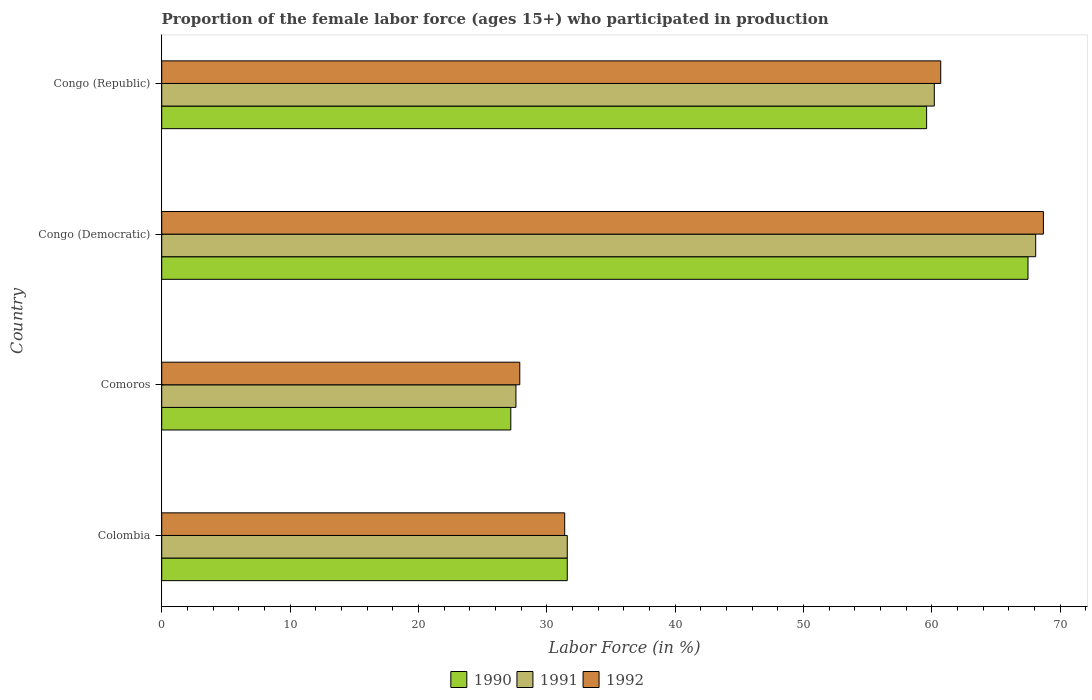How many groups of bars are there?
Provide a short and direct response. 4. Are the number of bars on each tick of the Y-axis equal?
Provide a succinct answer. Yes. What is the label of the 2nd group of bars from the top?
Offer a very short reply. Congo (Democratic). What is the proportion of the female labor force who participated in production in 1990 in Comoros?
Offer a terse response. 27.2. Across all countries, what is the maximum proportion of the female labor force who participated in production in 1992?
Provide a succinct answer. 68.7. Across all countries, what is the minimum proportion of the female labor force who participated in production in 1990?
Ensure brevity in your answer.  27.2. In which country was the proportion of the female labor force who participated in production in 1990 maximum?
Provide a succinct answer. Congo (Democratic). In which country was the proportion of the female labor force who participated in production in 1990 minimum?
Provide a short and direct response. Comoros. What is the total proportion of the female labor force who participated in production in 1991 in the graph?
Provide a short and direct response. 187.5. What is the difference between the proportion of the female labor force who participated in production in 1991 in Congo (Democratic) and that in Congo (Republic)?
Your answer should be compact. 7.9. What is the difference between the proportion of the female labor force who participated in production in 1991 in Comoros and the proportion of the female labor force who participated in production in 1990 in Colombia?
Your answer should be compact. -4. What is the average proportion of the female labor force who participated in production in 1992 per country?
Give a very brief answer. 47.17. What is the difference between the proportion of the female labor force who participated in production in 1992 and proportion of the female labor force who participated in production in 1990 in Colombia?
Your response must be concise. -0.2. What is the ratio of the proportion of the female labor force who participated in production in 1991 in Colombia to that in Comoros?
Ensure brevity in your answer.  1.14. What is the difference between the highest and the second highest proportion of the female labor force who participated in production in 1990?
Offer a very short reply. 7.9. What is the difference between the highest and the lowest proportion of the female labor force who participated in production in 1990?
Offer a very short reply. 40.3. Is the sum of the proportion of the female labor force who participated in production in 1990 in Congo (Democratic) and Congo (Republic) greater than the maximum proportion of the female labor force who participated in production in 1991 across all countries?
Offer a very short reply. Yes. How many bars are there?
Provide a succinct answer. 12. Are all the bars in the graph horizontal?
Give a very brief answer. Yes. Are the values on the major ticks of X-axis written in scientific E-notation?
Ensure brevity in your answer.  No. Does the graph contain any zero values?
Give a very brief answer. No. What is the title of the graph?
Provide a short and direct response. Proportion of the female labor force (ages 15+) who participated in production. Does "1984" appear as one of the legend labels in the graph?
Your response must be concise. No. What is the label or title of the X-axis?
Give a very brief answer. Labor Force (in %). What is the Labor Force (in %) in 1990 in Colombia?
Give a very brief answer. 31.6. What is the Labor Force (in %) in 1991 in Colombia?
Your response must be concise. 31.6. What is the Labor Force (in %) in 1992 in Colombia?
Provide a succinct answer. 31.4. What is the Labor Force (in %) of 1990 in Comoros?
Provide a succinct answer. 27.2. What is the Labor Force (in %) of 1991 in Comoros?
Offer a very short reply. 27.6. What is the Labor Force (in %) of 1992 in Comoros?
Your answer should be very brief. 27.9. What is the Labor Force (in %) in 1990 in Congo (Democratic)?
Keep it short and to the point. 67.5. What is the Labor Force (in %) in 1991 in Congo (Democratic)?
Your answer should be very brief. 68.1. What is the Labor Force (in %) in 1992 in Congo (Democratic)?
Give a very brief answer. 68.7. What is the Labor Force (in %) of 1990 in Congo (Republic)?
Your response must be concise. 59.6. What is the Labor Force (in %) in 1991 in Congo (Republic)?
Your answer should be compact. 60.2. What is the Labor Force (in %) of 1992 in Congo (Republic)?
Offer a very short reply. 60.7. Across all countries, what is the maximum Labor Force (in %) in 1990?
Your response must be concise. 67.5. Across all countries, what is the maximum Labor Force (in %) of 1991?
Your answer should be very brief. 68.1. Across all countries, what is the maximum Labor Force (in %) in 1992?
Keep it short and to the point. 68.7. Across all countries, what is the minimum Labor Force (in %) in 1990?
Provide a short and direct response. 27.2. Across all countries, what is the minimum Labor Force (in %) of 1991?
Offer a terse response. 27.6. Across all countries, what is the minimum Labor Force (in %) in 1992?
Provide a short and direct response. 27.9. What is the total Labor Force (in %) in 1990 in the graph?
Make the answer very short. 185.9. What is the total Labor Force (in %) in 1991 in the graph?
Make the answer very short. 187.5. What is the total Labor Force (in %) in 1992 in the graph?
Keep it short and to the point. 188.7. What is the difference between the Labor Force (in %) in 1991 in Colombia and that in Comoros?
Offer a very short reply. 4. What is the difference between the Labor Force (in %) of 1992 in Colombia and that in Comoros?
Provide a succinct answer. 3.5. What is the difference between the Labor Force (in %) in 1990 in Colombia and that in Congo (Democratic)?
Your answer should be compact. -35.9. What is the difference between the Labor Force (in %) of 1991 in Colombia and that in Congo (Democratic)?
Your answer should be compact. -36.5. What is the difference between the Labor Force (in %) of 1992 in Colombia and that in Congo (Democratic)?
Your response must be concise. -37.3. What is the difference between the Labor Force (in %) in 1991 in Colombia and that in Congo (Republic)?
Offer a terse response. -28.6. What is the difference between the Labor Force (in %) of 1992 in Colombia and that in Congo (Republic)?
Keep it short and to the point. -29.3. What is the difference between the Labor Force (in %) of 1990 in Comoros and that in Congo (Democratic)?
Make the answer very short. -40.3. What is the difference between the Labor Force (in %) in 1991 in Comoros and that in Congo (Democratic)?
Give a very brief answer. -40.5. What is the difference between the Labor Force (in %) of 1992 in Comoros and that in Congo (Democratic)?
Ensure brevity in your answer.  -40.8. What is the difference between the Labor Force (in %) of 1990 in Comoros and that in Congo (Republic)?
Offer a terse response. -32.4. What is the difference between the Labor Force (in %) in 1991 in Comoros and that in Congo (Republic)?
Give a very brief answer. -32.6. What is the difference between the Labor Force (in %) of 1992 in Comoros and that in Congo (Republic)?
Your response must be concise. -32.8. What is the difference between the Labor Force (in %) of 1992 in Congo (Democratic) and that in Congo (Republic)?
Keep it short and to the point. 8. What is the difference between the Labor Force (in %) in 1990 in Colombia and the Labor Force (in %) in 1991 in Comoros?
Give a very brief answer. 4. What is the difference between the Labor Force (in %) of 1991 in Colombia and the Labor Force (in %) of 1992 in Comoros?
Provide a succinct answer. 3.7. What is the difference between the Labor Force (in %) in 1990 in Colombia and the Labor Force (in %) in 1991 in Congo (Democratic)?
Provide a short and direct response. -36.5. What is the difference between the Labor Force (in %) in 1990 in Colombia and the Labor Force (in %) in 1992 in Congo (Democratic)?
Keep it short and to the point. -37.1. What is the difference between the Labor Force (in %) of 1991 in Colombia and the Labor Force (in %) of 1992 in Congo (Democratic)?
Keep it short and to the point. -37.1. What is the difference between the Labor Force (in %) of 1990 in Colombia and the Labor Force (in %) of 1991 in Congo (Republic)?
Your answer should be very brief. -28.6. What is the difference between the Labor Force (in %) in 1990 in Colombia and the Labor Force (in %) in 1992 in Congo (Republic)?
Offer a terse response. -29.1. What is the difference between the Labor Force (in %) of 1991 in Colombia and the Labor Force (in %) of 1992 in Congo (Republic)?
Your response must be concise. -29.1. What is the difference between the Labor Force (in %) of 1990 in Comoros and the Labor Force (in %) of 1991 in Congo (Democratic)?
Give a very brief answer. -40.9. What is the difference between the Labor Force (in %) of 1990 in Comoros and the Labor Force (in %) of 1992 in Congo (Democratic)?
Ensure brevity in your answer.  -41.5. What is the difference between the Labor Force (in %) in 1991 in Comoros and the Labor Force (in %) in 1992 in Congo (Democratic)?
Provide a succinct answer. -41.1. What is the difference between the Labor Force (in %) of 1990 in Comoros and the Labor Force (in %) of 1991 in Congo (Republic)?
Offer a terse response. -33. What is the difference between the Labor Force (in %) in 1990 in Comoros and the Labor Force (in %) in 1992 in Congo (Republic)?
Your answer should be very brief. -33.5. What is the difference between the Labor Force (in %) of 1991 in Comoros and the Labor Force (in %) of 1992 in Congo (Republic)?
Offer a very short reply. -33.1. What is the difference between the Labor Force (in %) of 1991 in Congo (Democratic) and the Labor Force (in %) of 1992 in Congo (Republic)?
Ensure brevity in your answer.  7.4. What is the average Labor Force (in %) of 1990 per country?
Offer a terse response. 46.48. What is the average Labor Force (in %) of 1991 per country?
Your answer should be very brief. 46.88. What is the average Labor Force (in %) in 1992 per country?
Ensure brevity in your answer.  47.17. What is the difference between the Labor Force (in %) in 1990 and Labor Force (in %) in 1992 in Colombia?
Make the answer very short. 0.2. What is the difference between the Labor Force (in %) in 1991 and Labor Force (in %) in 1992 in Congo (Democratic)?
Keep it short and to the point. -0.6. What is the difference between the Labor Force (in %) of 1990 and Labor Force (in %) of 1991 in Congo (Republic)?
Your answer should be very brief. -0.6. What is the ratio of the Labor Force (in %) in 1990 in Colombia to that in Comoros?
Your answer should be compact. 1.16. What is the ratio of the Labor Force (in %) in 1991 in Colombia to that in Comoros?
Offer a very short reply. 1.14. What is the ratio of the Labor Force (in %) of 1992 in Colombia to that in Comoros?
Ensure brevity in your answer.  1.13. What is the ratio of the Labor Force (in %) in 1990 in Colombia to that in Congo (Democratic)?
Provide a short and direct response. 0.47. What is the ratio of the Labor Force (in %) in 1991 in Colombia to that in Congo (Democratic)?
Offer a terse response. 0.46. What is the ratio of the Labor Force (in %) in 1992 in Colombia to that in Congo (Democratic)?
Provide a succinct answer. 0.46. What is the ratio of the Labor Force (in %) in 1990 in Colombia to that in Congo (Republic)?
Your answer should be very brief. 0.53. What is the ratio of the Labor Force (in %) of 1991 in Colombia to that in Congo (Republic)?
Keep it short and to the point. 0.52. What is the ratio of the Labor Force (in %) in 1992 in Colombia to that in Congo (Republic)?
Your answer should be compact. 0.52. What is the ratio of the Labor Force (in %) in 1990 in Comoros to that in Congo (Democratic)?
Keep it short and to the point. 0.4. What is the ratio of the Labor Force (in %) in 1991 in Comoros to that in Congo (Democratic)?
Your answer should be very brief. 0.41. What is the ratio of the Labor Force (in %) in 1992 in Comoros to that in Congo (Democratic)?
Make the answer very short. 0.41. What is the ratio of the Labor Force (in %) of 1990 in Comoros to that in Congo (Republic)?
Offer a very short reply. 0.46. What is the ratio of the Labor Force (in %) of 1991 in Comoros to that in Congo (Republic)?
Offer a very short reply. 0.46. What is the ratio of the Labor Force (in %) in 1992 in Comoros to that in Congo (Republic)?
Make the answer very short. 0.46. What is the ratio of the Labor Force (in %) of 1990 in Congo (Democratic) to that in Congo (Republic)?
Offer a very short reply. 1.13. What is the ratio of the Labor Force (in %) of 1991 in Congo (Democratic) to that in Congo (Republic)?
Your answer should be compact. 1.13. What is the ratio of the Labor Force (in %) of 1992 in Congo (Democratic) to that in Congo (Republic)?
Ensure brevity in your answer.  1.13. What is the difference between the highest and the second highest Labor Force (in %) of 1990?
Make the answer very short. 7.9. What is the difference between the highest and the second highest Labor Force (in %) of 1991?
Your answer should be compact. 7.9. What is the difference between the highest and the lowest Labor Force (in %) in 1990?
Ensure brevity in your answer.  40.3. What is the difference between the highest and the lowest Labor Force (in %) in 1991?
Offer a very short reply. 40.5. What is the difference between the highest and the lowest Labor Force (in %) in 1992?
Ensure brevity in your answer.  40.8. 